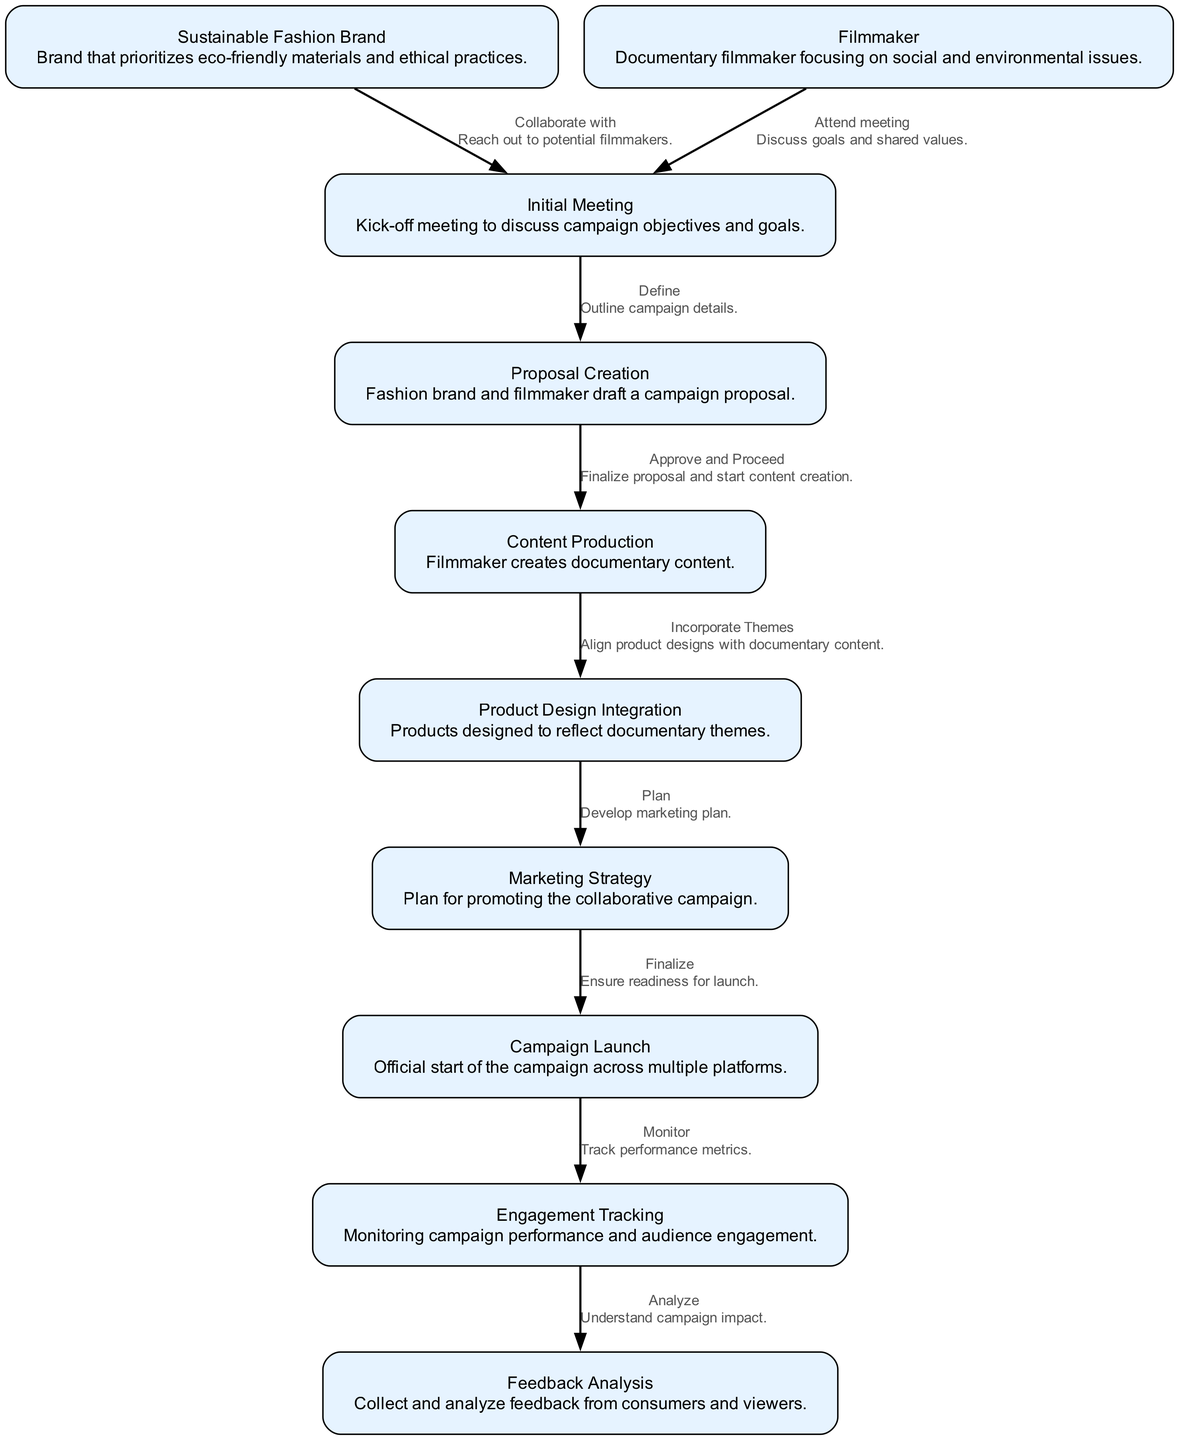What is the first step in the workflow? The first step in the workflow as indicated in the diagram is "Initial Meeting." It is the starting point where both the sustainable fashion brand and the filmmaker come together to discuss campaign objectives and goals.
Answer: Initial Meeting How many nodes are there in the diagram? By counting all the distinct elements (points of interest) presented in the diagram, we find there are ten nodes: Sustainable Fashion Brand, Filmmaker, Initial Meeting, Proposal Creation, Content Production, Product Design Integration, Marketing Strategy, Campaign Launch, Engagement Tracking, and Feedback Analysis.
Answer: Ten What does the filmmaker do after the initial meeting? After the initial meeting, the filmmaker moves to the "Proposal Creation" node, where both parties draft a campaign proposal, outlining their shared goals and vision.
Answer: Proposal Creation What happens after the proposal creation? Following the completion of the proposal, the next step is "Content Production." At this stage, the filmmaker begins creating documentary content based on the agreed proposal, which serves as a foundation for the campaign.
Answer: Content Production What is the relationship between "Content Production" and "Product Design Integration"? The relationship shown in the diagram indicates that "Content Production" influences "Product Design Integration" by incorporating themes from the documentary into product designs. This means that the designs of the products will reflect the messages and themes highlighted in the content created.
Answer: Incorporate Themes Which node monitors campaign performance? The node responsible for monitoring campaign performance is "Engagement Tracking." This step entails tracking how the audience interacts with the campaign, measuring various performance metrics to assess effectiveness.
Answer: Engagement Tracking What is the final step in the workflow? The final step in the workflow is "Feedback Analysis." This involves collecting and analyzing feedback from consumers and viewers after the campaign has been launched, helping to understand its impact and reach.
Answer: Feedback Analysis How do the marketing strategy and campaign launch connect? The diagram depicts a direct connection between "Marketing Strategy" and "Campaign Launch." After finalizing the marketing plan, the campaign is officially launched across multiple platforms, indicating a seamless transition from planning to execution.
Answer: Finalize What is the role of the sustainable fashion brand in the initial meeting? The sustainable fashion brand's role in the initial meeting is to collaborate with a potential filmmaker. This involves reaching out to filmmakers who share similar values and discussing the collaborative efforts that could emerge from their partnership.
Answer: Collaborate with 